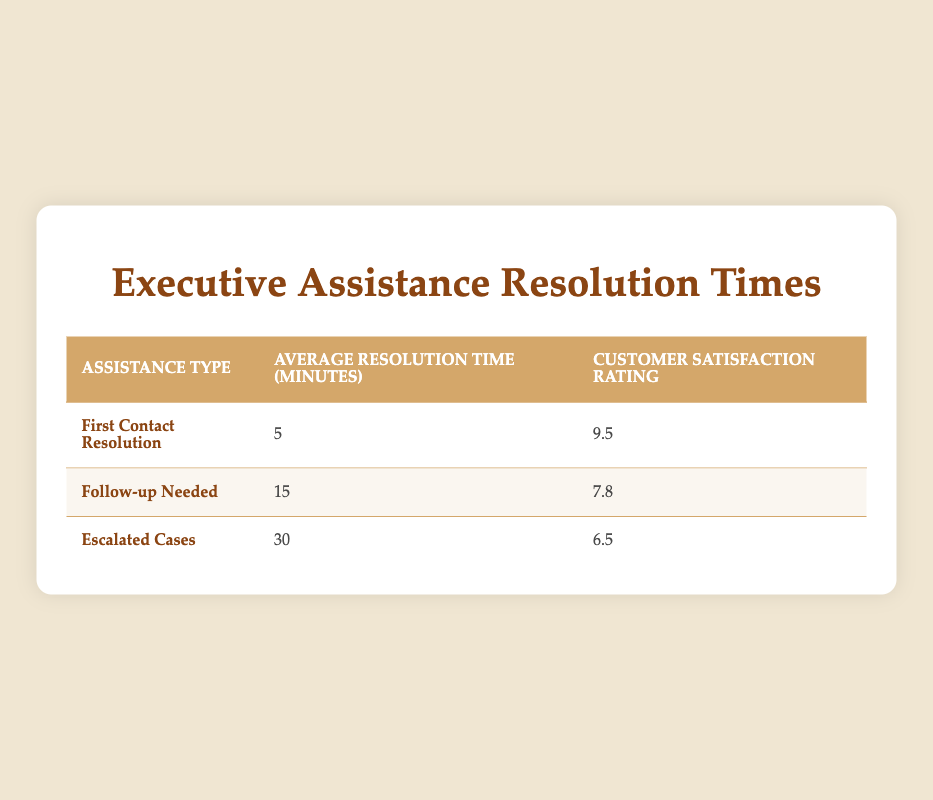What is the average resolution time for First Contact Resolution? The table shows the average resolution time for each assistance type. For First Contact Resolution, the average resolution time is directly stated as 5 minutes.
Answer: 5 minutes What is the customer satisfaction rating for Follow-up Needed assistance? According to the table, the customer satisfaction rating for Follow-up Needed is listed as 7.8.
Answer: 7.8 How much longer on average does it take to resolve Escalated Cases compared to First Contact Resolution? The average resolution time for Escalated Cases is 30 minutes, while for First Contact Resolution it is 5 minutes. To find the difference, subtract: 30 minutes - 5 minutes = 25 minutes.
Answer: 25 minutes Is the average resolution time for Follow-up Needed less than that for First Contact Resolution? The average resolution time for Follow-up Needed is 15 minutes, which is greater than the 5 minutes for First Contact Resolution. Therefore, the statement is false.
Answer: No What is the overall average of the customer satisfaction ratings across all assistance types? To find the overall average satisfaction rating, sum the ratings: (9.5 + 7.8 + 6.5) = 23.8. Then, divide this sum by the number of assistance types, which is 3: 23.8 / 3 = 7.9333. Rounding gives approximately 7.93.
Answer: 7.93 Which assistance type has the highest customer satisfaction rating? By checking the customer satisfaction ratings, First Contact Resolution has the highest rating of 9.5, compared to 7.8 for Follow-up Needed and 6.5 for Escalated Cases.
Answer: First Contact Resolution What is the difference in average resolution time between Follow-up Needed and Escalated Cases? The average resolution time for Follow-up Needed is 15 minutes and for Escalated Cases, it is 30 minutes. The difference can be calculated by subtracting: 30 minutes - 15 minutes = 15 minutes.
Answer: 15 minutes Are customers generally more satisfied with First Contact Resolution or Escalated Cases? The customer satisfaction rating for First Contact Resolution is 9.5, while for Escalated Cases it is 6.5. Since 9.5 is greater than 6.5, customers are generally more satisfied with First Contact Resolution.
Answer: Yes 